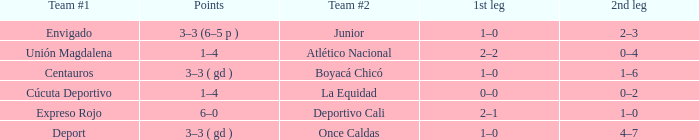What occurs during the first leg for junior team #2? 1–0. 